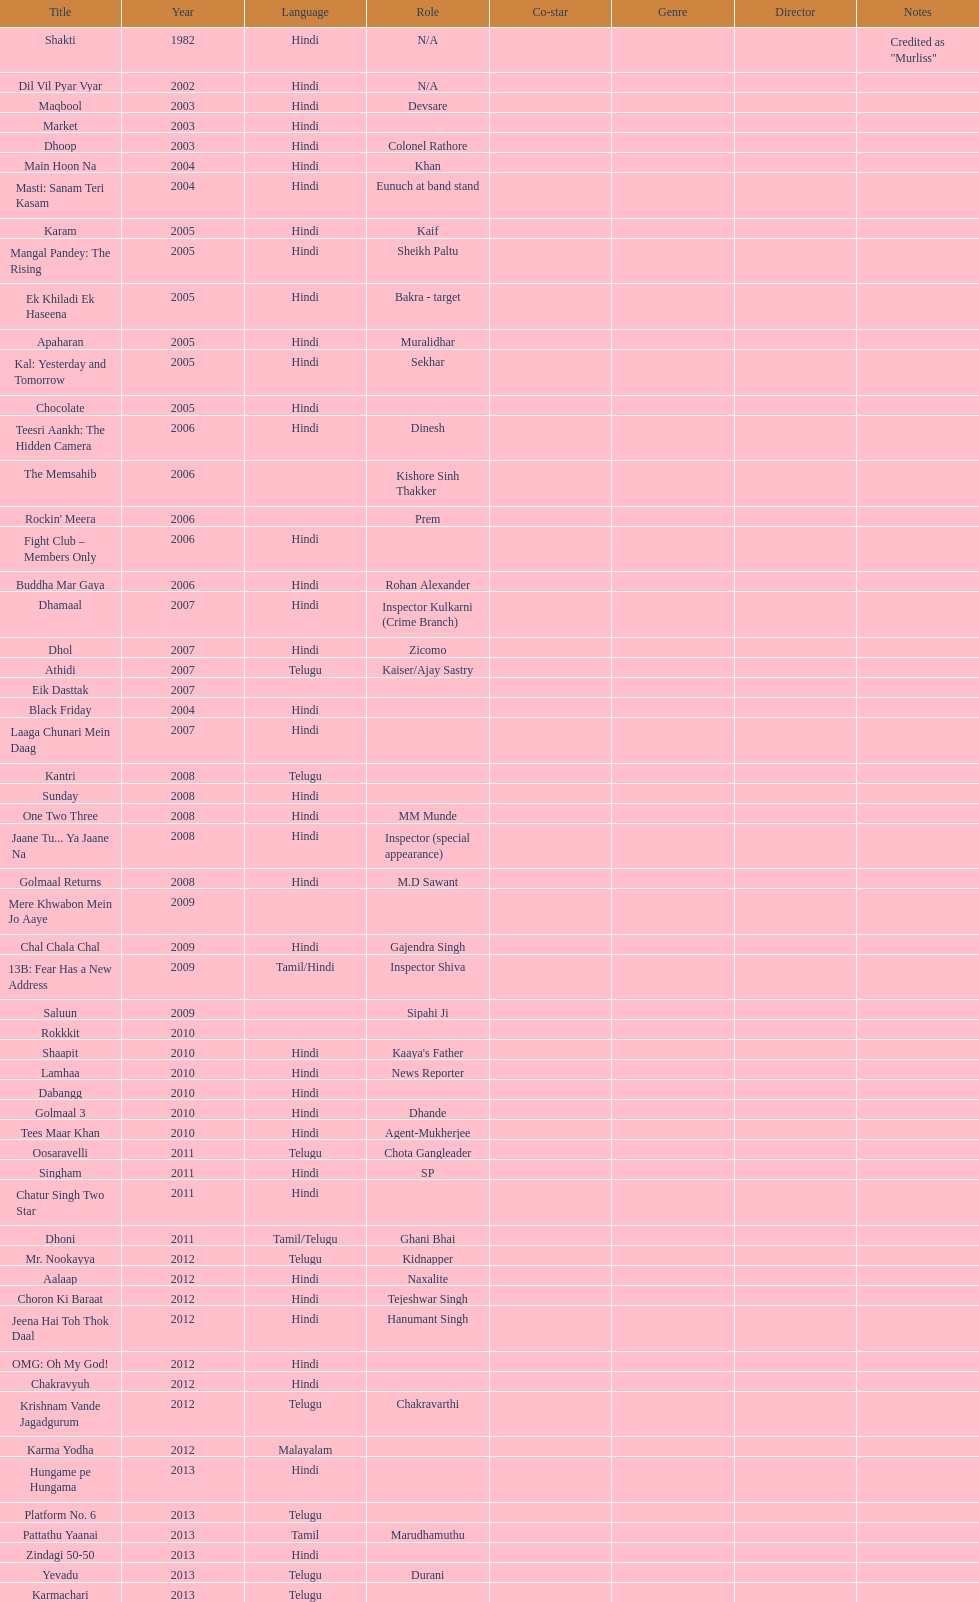Does maqbool have longer notes than shakti? No. 